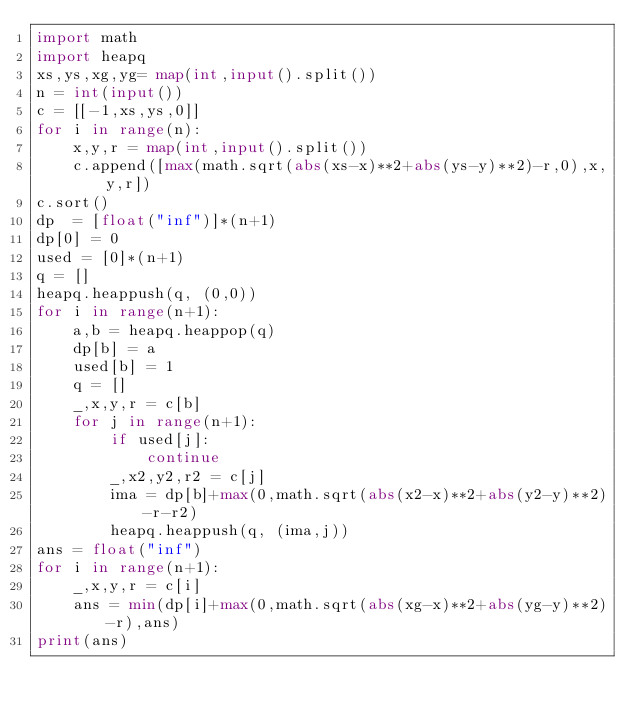<code> <loc_0><loc_0><loc_500><loc_500><_Python_>import math
import heapq
xs,ys,xg,yg= map(int,input().split())
n = int(input())
c = [[-1,xs,ys,0]]
for i in range(n):
    x,y,r = map(int,input().split())
    c.append([max(math.sqrt(abs(xs-x)**2+abs(ys-y)**2)-r,0),x,y,r])
c.sort()
dp  = [float("inf")]*(n+1)
dp[0] = 0
used = [0]*(n+1)
q = []
heapq.heappush(q, (0,0))
for i in range(n+1):
    a,b = heapq.heappop(q)
    dp[b] = a
    used[b] = 1
    q = []
    _,x,y,r = c[b]
    for j in range(n+1):
        if used[j]:
            continue
        _,x2,y2,r2 = c[j]
        ima = dp[b]+max(0,math.sqrt(abs(x2-x)**2+abs(y2-y)**2)-r-r2)
        heapq.heappush(q, (ima,j))
ans = float("inf")
for i in range(n+1):
    _,x,y,r = c[i]
    ans = min(dp[i]+max(0,math.sqrt(abs(xg-x)**2+abs(yg-y)**2)-r),ans)
print(ans)</code> 